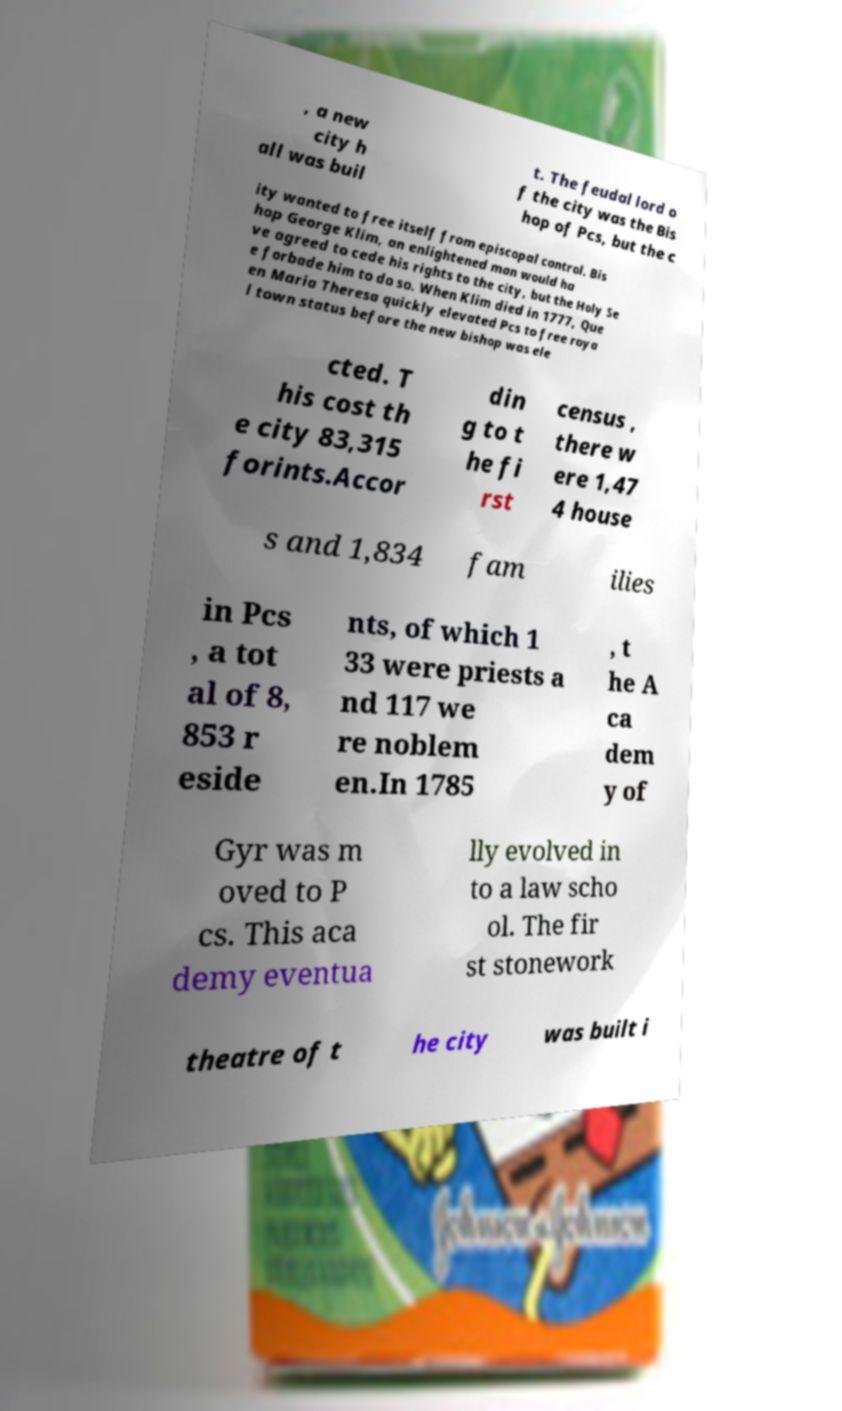Please read and relay the text visible in this image. What does it say? , a new city h all was buil t. The feudal lord o f the city was the Bis hop of Pcs, but the c ity wanted to free itself from episcopal control. Bis hop George Klim, an enlightened man would ha ve agreed to cede his rights to the city, but the Holy Se e forbade him to do so. When Klim died in 1777, Que en Maria Theresa quickly elevated Pcs to free roya l town status before the new bishop was ele cted. T his cost th e city 83,315 forints.Accor din g to t he fi rst census , there w ere 1,47 4 house s and 1,834 fam ilies in Pcs , a tot al of 8, 853 r eside nts, of which 1 33 were priests a nd 117 we re noblem en.In 1785 , t he A ca dem y of Gyr was m oved to P cs. This aca demy eventua lly evolved in to a law scho ol. The fir st stonework theatre of t he city was built i 